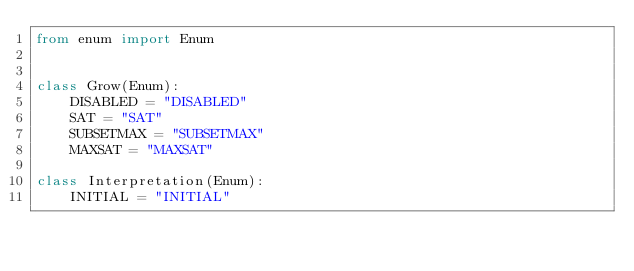Convert code to text. <code><loc_0><loc_0><loc_500><loc_500><_Python_>from enum import Enum


class Grow(Enum):
    DISABLED = "DISABLED"
    SAT = "SAT"
    SUBSETMAX = "SUBSETMAX"
    MAXSAT = "MAXSAT"

class Interpretation(Enum):
    INITIAL = "INITIAL"</code> 